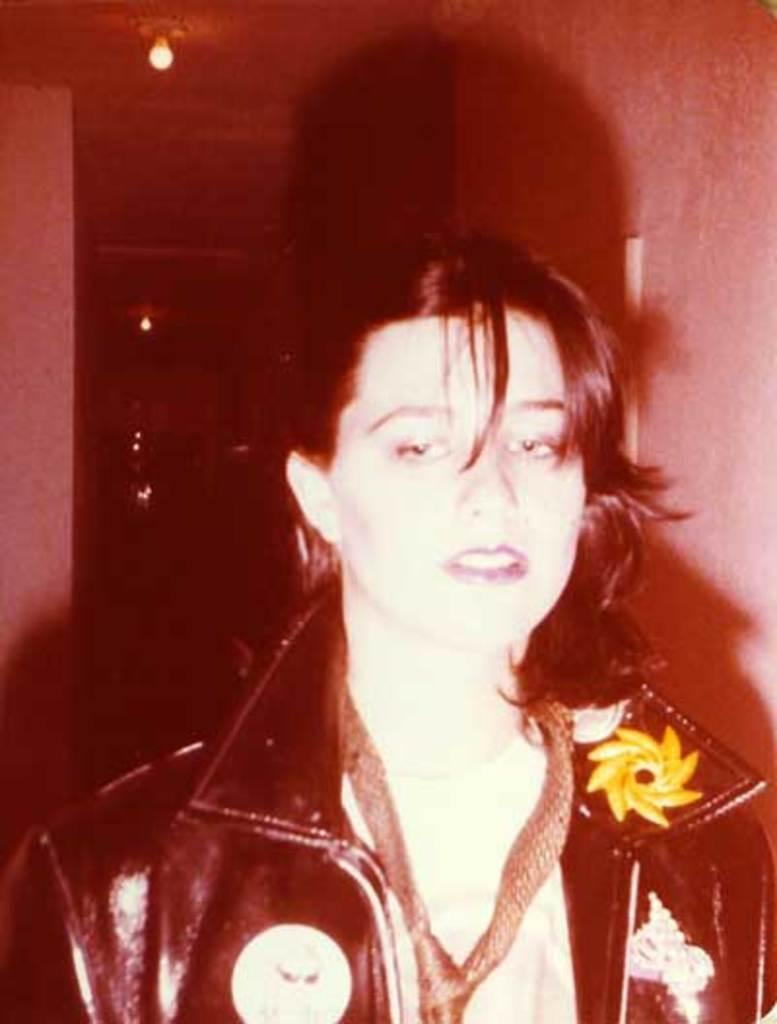Who is the main subject in the image? There is a woman in the center of the image. What is the woman wearing? The woman is wearing a black jacket. What can be seen in the background of the image? There are lights and a wall in the background of the image. How often does the woman cough in the image? There is no indication of the woman coughing in the image. What type of hairstyle does the woman have in the image? The provided facts do not mention the woman's hairstyle. 